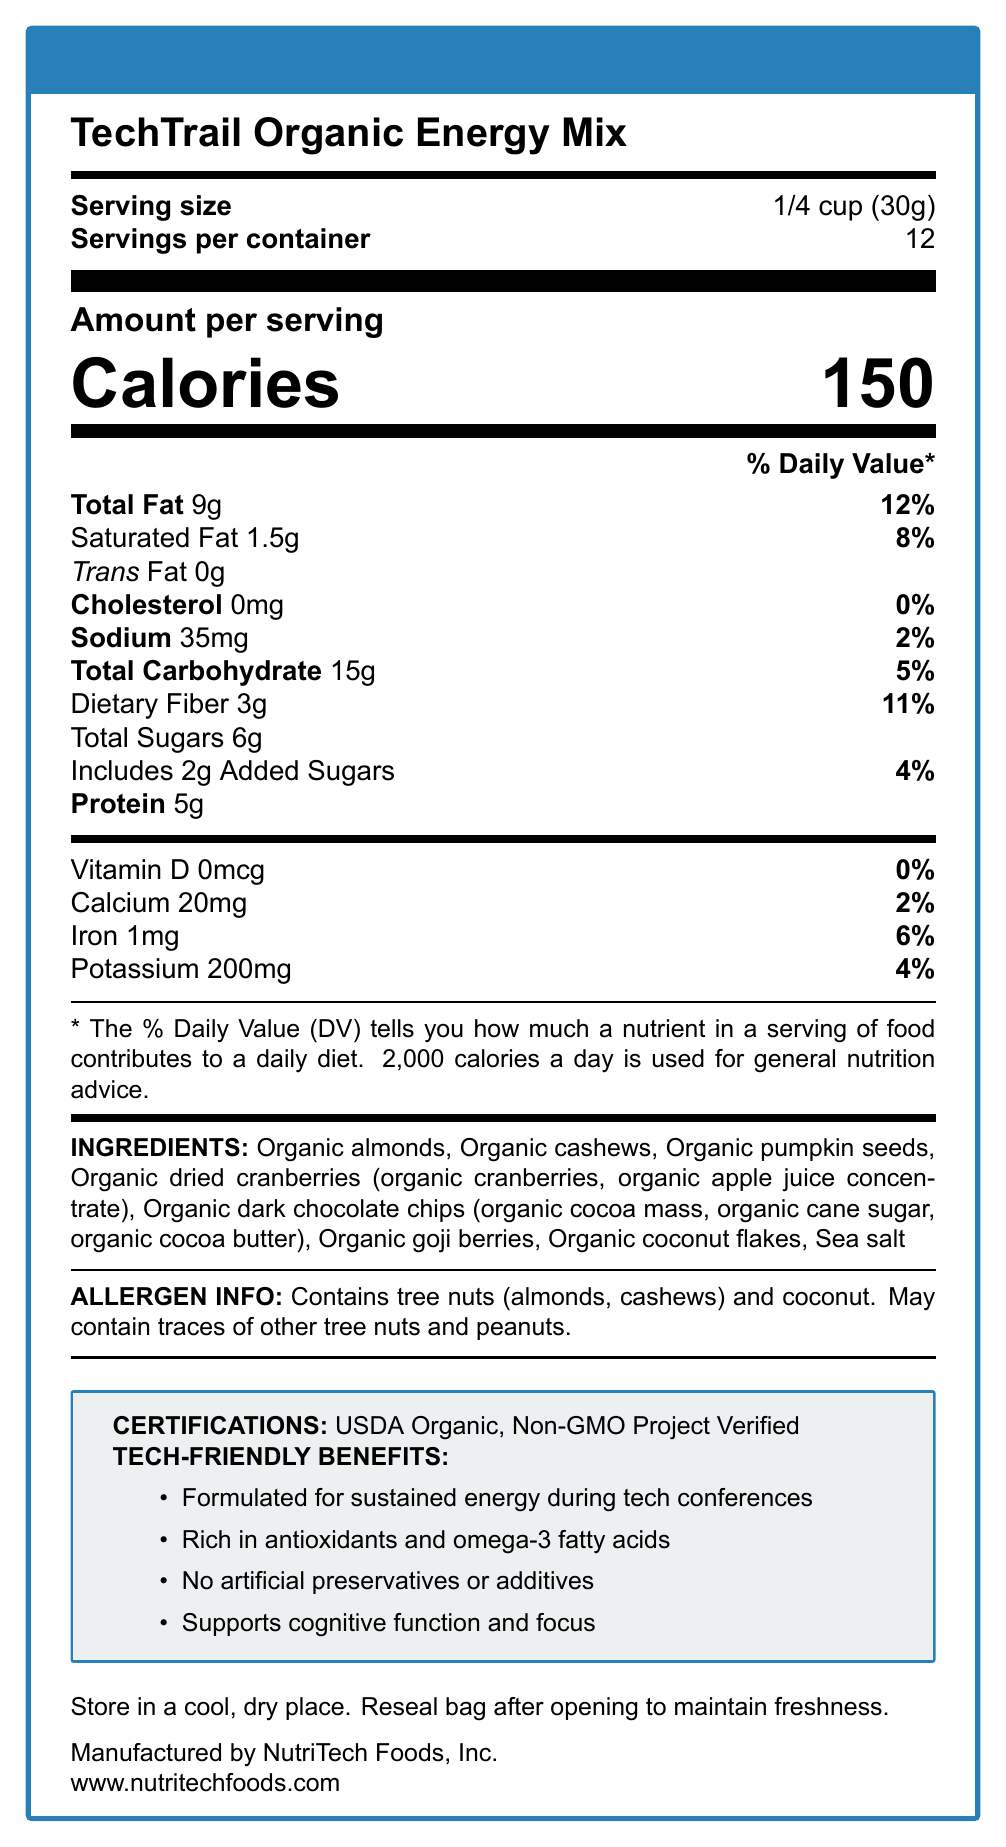what is the serving size of TechTrail Organic Energy Mix? The document specifies that the serving size is 1/4 cup or 30 grams.
Answer: 1/4 cup (30g) How many servings are there per container? The document states that there are 12 servings per container.
Answer: 12 What is the total fat content per serving? The document lists the total fat content per serving as 9 grams.
Answer: 9g What percentage of the daily value of iron does one serving contain? According to the document, one serving contains 6% of the daily value of iron.
Answer: 6% What are some of the ingredients in the TechTrail Organic Energy Mix? Some of the ingredients listed in the document include organic almonds, organic cashews, and organic pumpkin seeds, among others.
Answer: Organic almonds, Organic cashews, Organic pumpkin seeds, etc. What are the certifications mentioned in the document? A. FDA Approved B. USDA Organic C. Gluten-Free Certified The document specifies that the product is USDA Organic and Non-GMO Project Verified.
Answer: B What is the amount of added sugars per serving? A. 0g B. 1g C. 2g D. 3g The document indicates that there are 2 grams of added sugars per serving.
Answer: C Does the product contain any artificial preservatives or additives? The document claims that the product has no artificial preservatives or additives.
Answer: No Is this product suitable for someone with a peanut allergy? The document states that while it contains tree nuts and coconut, it may also contain traces of other tree nuts and peanuts.
Answer: No Summarize the main benefits and characteristics of TechTrail Organic Energy Mix. The document provides information on the product's certifications, ingredients, nutritional content, and its specific benefits for tech conference attendees.
Answer: The TechTrail Organic Energy Mix is a USDA Organic and Non-GMO Project Verified trail mix designed for sustained energy during tech conferences. It contains a blend of organic almonds, cashews, pumpkin seeds, dried cranberries, dark chocolate chips, goji berries, coconut flakes, and sea salt. It is rich in antioxidants, omega-3 fatty acids, and supports cognitive function and focus. The product does not contain any artificial preservatives or additives. How many grams of dietary fiber are there in each serving? The document specifies that there are 3 grams of dietary fiber per serving.
Answer: 3g What is the daily percentage value of saturated fat in one serving? The document indicates that the daily value percentage of saturated fat in one serving is 8%.
Answer: 8% Who is the manufacturer of the TechTrail Organic Energy Mix? The document lists NutriTech Foods, Inc. as the manufacturer.
Answer: NutriTech Foods, Inc. What type of nuts does this product contain? The document states that the product contains tree nuts, specifically almonds and cashews, as well as coconut.
Answer: Tree nuts (almonds, cashews) and coconut What does the document say about storing the product? The document advises to store the trail mix in a cool, dry place and to reseal the bag after opening to maintain freshness.
Answer: Store in a cool, dry place. Reseal bag after opening to maintain freshness. What are the marketing claims associated with TechTrail Organic Energy Mix? The document lists several marketing claims including sustained energy, antioxidants and omega-3 fatty acids, lack of artificial preservatives or additives, and support for cognitive function.
Answer: Formulated for sustained energy during tech conferences, Rich in antioxidants and omega-3 fatty acids, No artificial preservatives or additives, Supports cognitive function and focus What is the website for more information about the product? The document provides the website www.nutritechfoods.com for more information.
Answer: www.nutritechfoods.com Does this product contain cholesterol? The document lists cholesterol as 0mg, indicating that the product does not contain cholesterol.
Answer: No Is the exact manufacturing date of the product mentioned? The document does not provide any specific details about the manufacturing date of the product.
Answer: Not enough information What is the total carbohydrate content per serving? The document indicates that there are 15 grams of total carbohydrates per serving.
Answer: 15g 